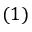Convert formula to latex. <formula><loc_0><loc_0><loc_500><loc_500>( 1 )</formula> 